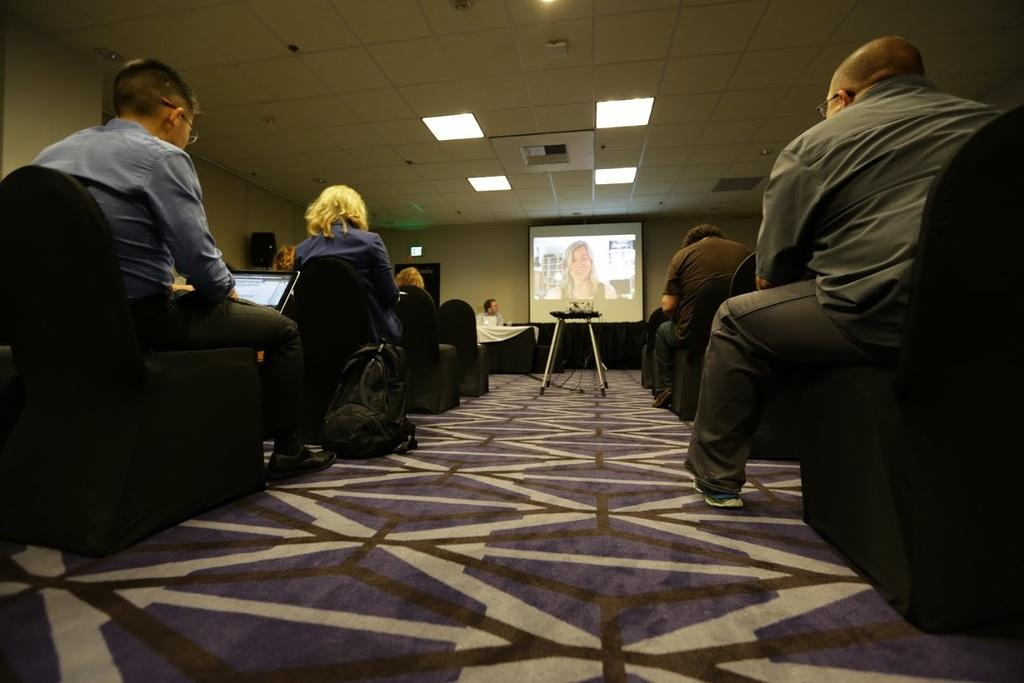What are the people in the image doing? The people are sitting in chairs. Where are the people located? The people are in a conference hall. What is in the center of the room? There is a screen in the center of the room. What is happening on the screen? A clip is playing on the screen. What type of religious ceremony is taking place in the image? There is no indication of a religious ceremony in the image; the people are in a conference hall, and a clip is playing on the screen. Can you tell me which judge is presiding over the trial in the image? There is no trial or judge present in the image; it features people sitting in chairs in a conference hall with a screen displaying a clip. 